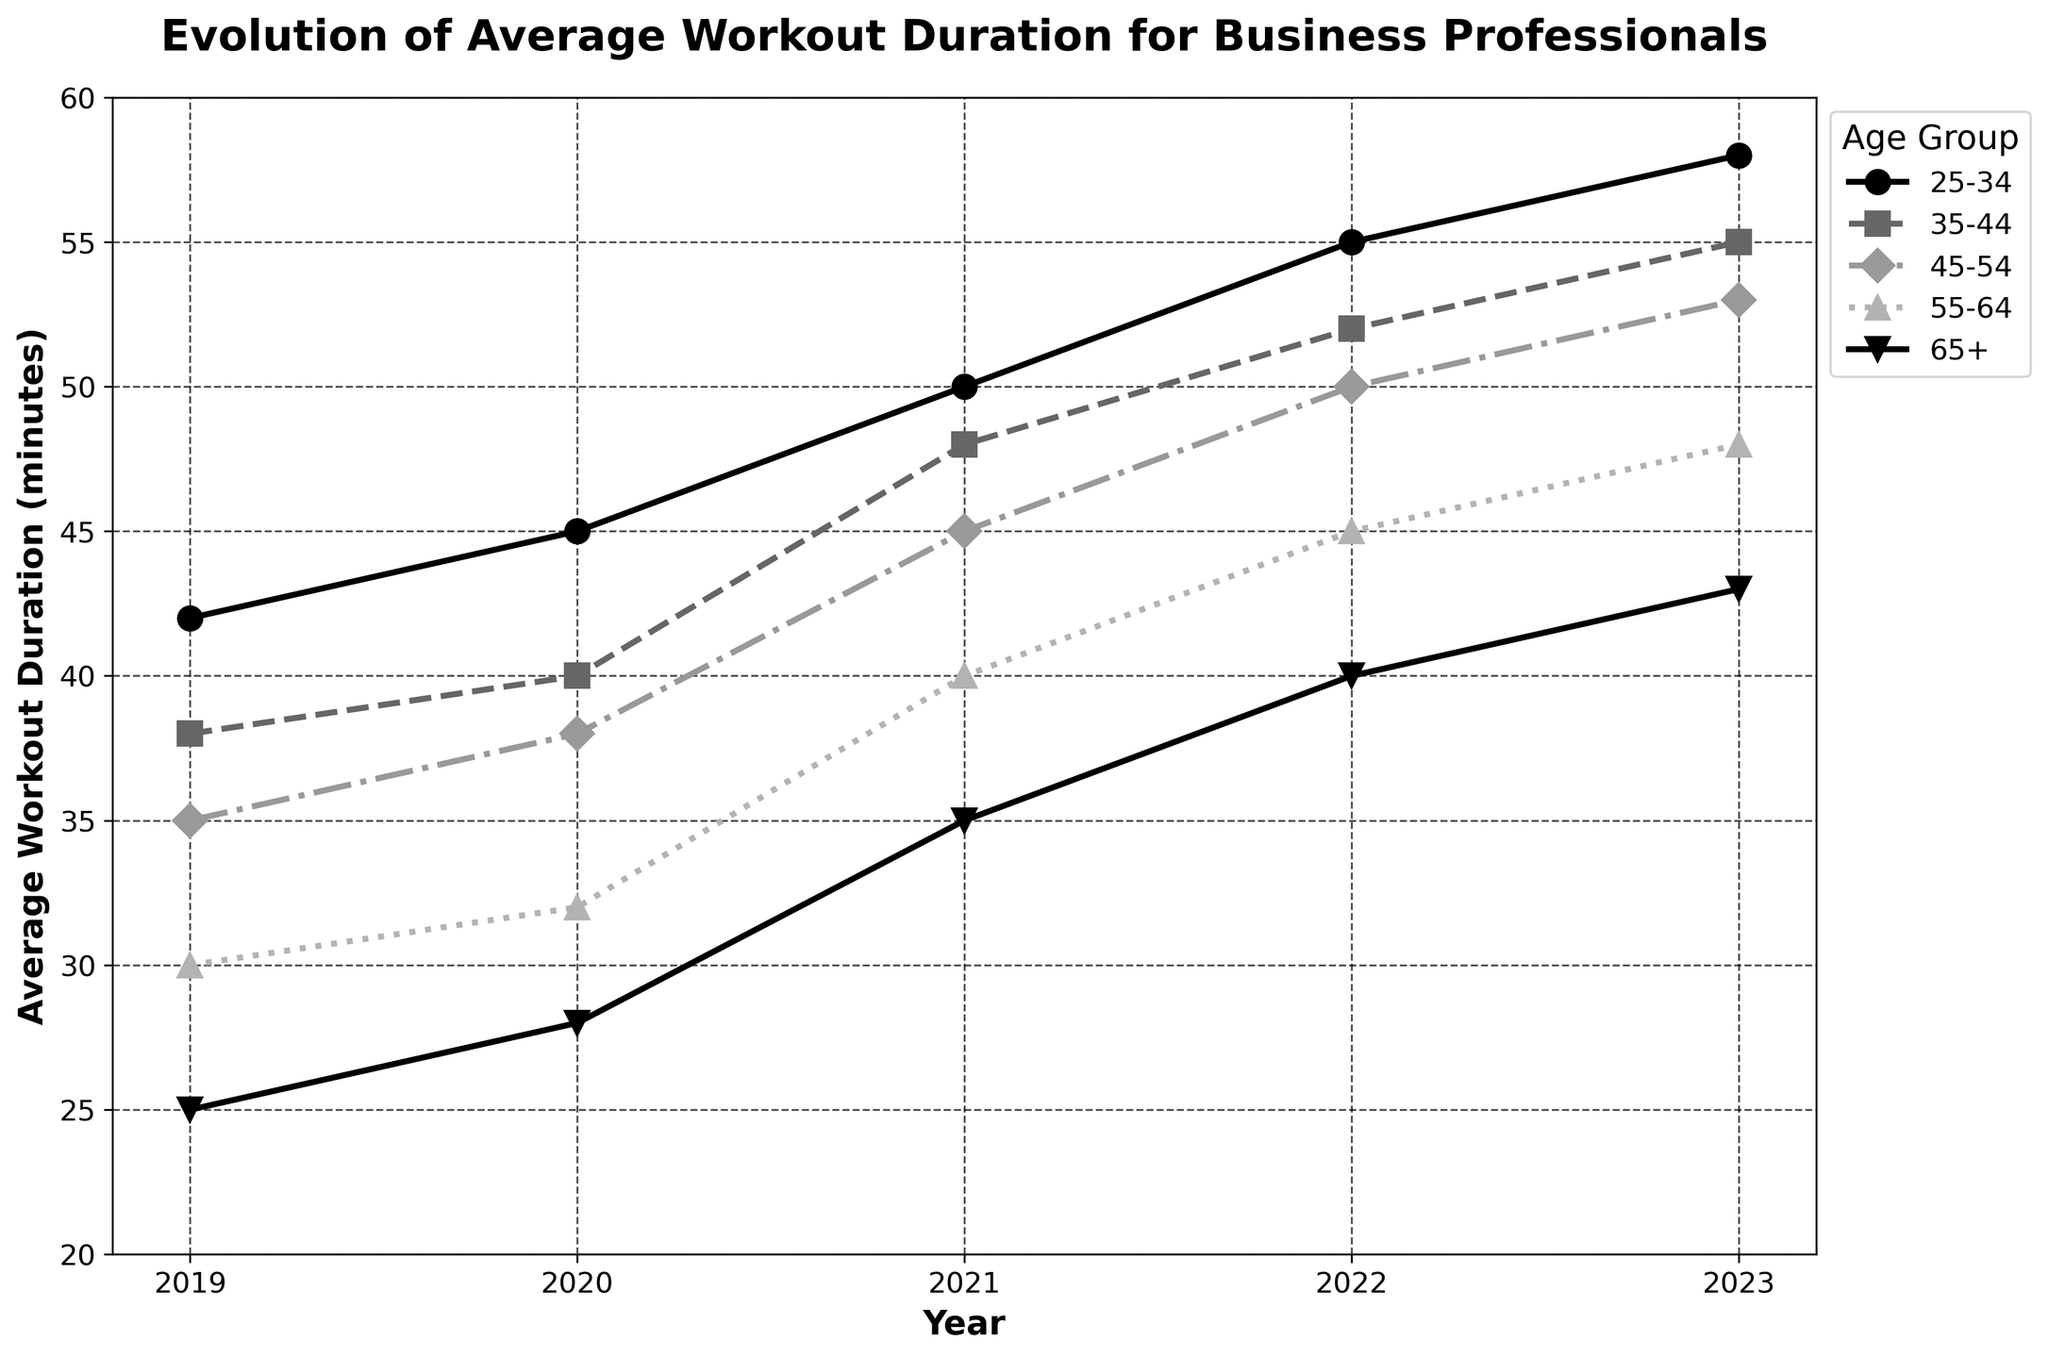What age group saw the highest increase in average workout duration from 2019 to 2023? First, calculate the increase in workout duration for each age group from 2019 to 2023: 
25-34: 58 - 42 = 16 
35-44: 55 - 38 = 17 
45-54: 53 - 35 = 18 
55-64: 48 - 30 = 18 
65+: 43 - 25 = 18 
Then, compare these values to find the highest one, which is 18. Therefore, the age groups 45-54, 55-64, and 65+ all had the highest increase, shared equally.
Answer: 45-54, 55-64, 65+ Which year had the largest increase in average workout duration for the 35-44 age group? Calculate the year-over-year increase for the 35-44 age group: 
2020-2019: 40 - 38 = 2 
2021-2020: 48 - 40 = 8 
2022-2021: 52 - 48 = 4 
2023-2022: 55 - 52 = 3 
The largest increase occurs between 2020 and 2021, which is 8.
Answer: 2021 Between which two consecutive years did the 25-34 age group experience the smallest increase in average workout duration? Calculate the year-over-year increase for the 25-34 age group: 
2020-2019: 45 - 42 = 3 
2021-2020: 50 - 45 = 5 
2022-2021: 55 - 50 = 5 
2023-2022: 58 - 55 = 3 
The smallest increase occurs between 2019-2020 and 2022-2023, both of which are 3.
Answer: 2019-2020, 2022-2023 What is the average workout duration for the 55-64 age group over the 5 years? First, sum the average workout durations for each year for the 55-64 age group: 
30 + 32 + 40 + 45 + 48 = 195 
Then, divide by the number of years, which is 5: 
195 / 5 = 39
Answer: 39 In which year did the 45-54 age group surpass the 35-44 age group in average workout duration? Compare the values of each year side-by-side:
2019: 35 (45-54) < 38 (35-44)
2020: 38 (45-54) < 40 (35-44)
2021: 45 (45-54) < 48 (35-44)
2022: 50 (45-54) < 52 (35-44)
2023: 53 (45-54) < 55 (35-44)
Thus, 45-54 never surpasses 35-44 in any year.
Answer: Never In which year did the 65+ age group have the same average workout duration as the 55-64 age group? Compare the average workout duration for 65+ and 55-64 age groups for each year:
2019: 25 (65+) ≠ 30 (55-64)
2020: 28 (65+) ≠ 32 (55-64)
2021: 35 (65+) = 40 (55-64)
2022: 40 (65+) = 45 (55-64)
2023: 43 (65+) ≠ 48 (55-64)
The average is the same for 2021 and 2022.
Answer: 2021, 2022 